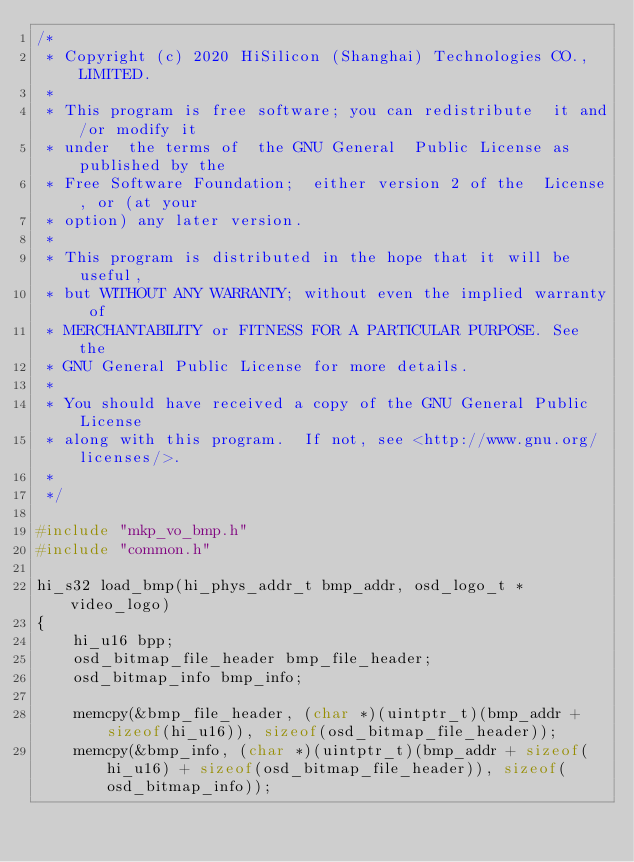Convert code to text. <code><loc_0><loc_0><loc_500><loc_500><_C_>/*
 * Copyright (c) 2020 HiSilicon (Shanghai) Technologies CO., LIMITED.
 *
 * This program is free software; you can redistribute  it and/or modify it
 * under  the terms of  the GNU General  Public License as published by the
 * Free Software Foundation;  either version 2 of the  License, or (at your
 * option) any later version.
 *
 * This program is distributed in the hope that it will be useful,
 * but WITHOUT ANY WARRANTY; without even the implied warranty of
 * MERCHANTABILITY or FITNESS FOR A PARTICULAR PURPOSE. See the
 * GNU General Public License for more details.
 *
 * You should have received a copy of the GNU General Public License
 * along with this program.  If not, see <http://www.gnu.org/licenses/>.
 *
 */

#include "mkp_vo_bmp.h"
#include "common.h"

hi_s32 load_bmp(hi_phys_addr_t bmp_addr, osd_logo_t *video_logo)
{
    hi_u16 bpp;
    osd_bitmap_file_header bmp_file_header;
    osd_bitmap_info bmp_info;

    memcpy(&bmp_file_header, (char *)(uintptr_t)(bmp_addr + sizeof(hi_u16)), sizeof(osd_bitmap_file_header));
    memcpy(&bmp_info, (char *)(uintptr_t)(bmp_addr + sizeof(hi_u16) + sizeof(osd_bitmap_file_header)), sizeof(osd_bitmap_info));</code> 